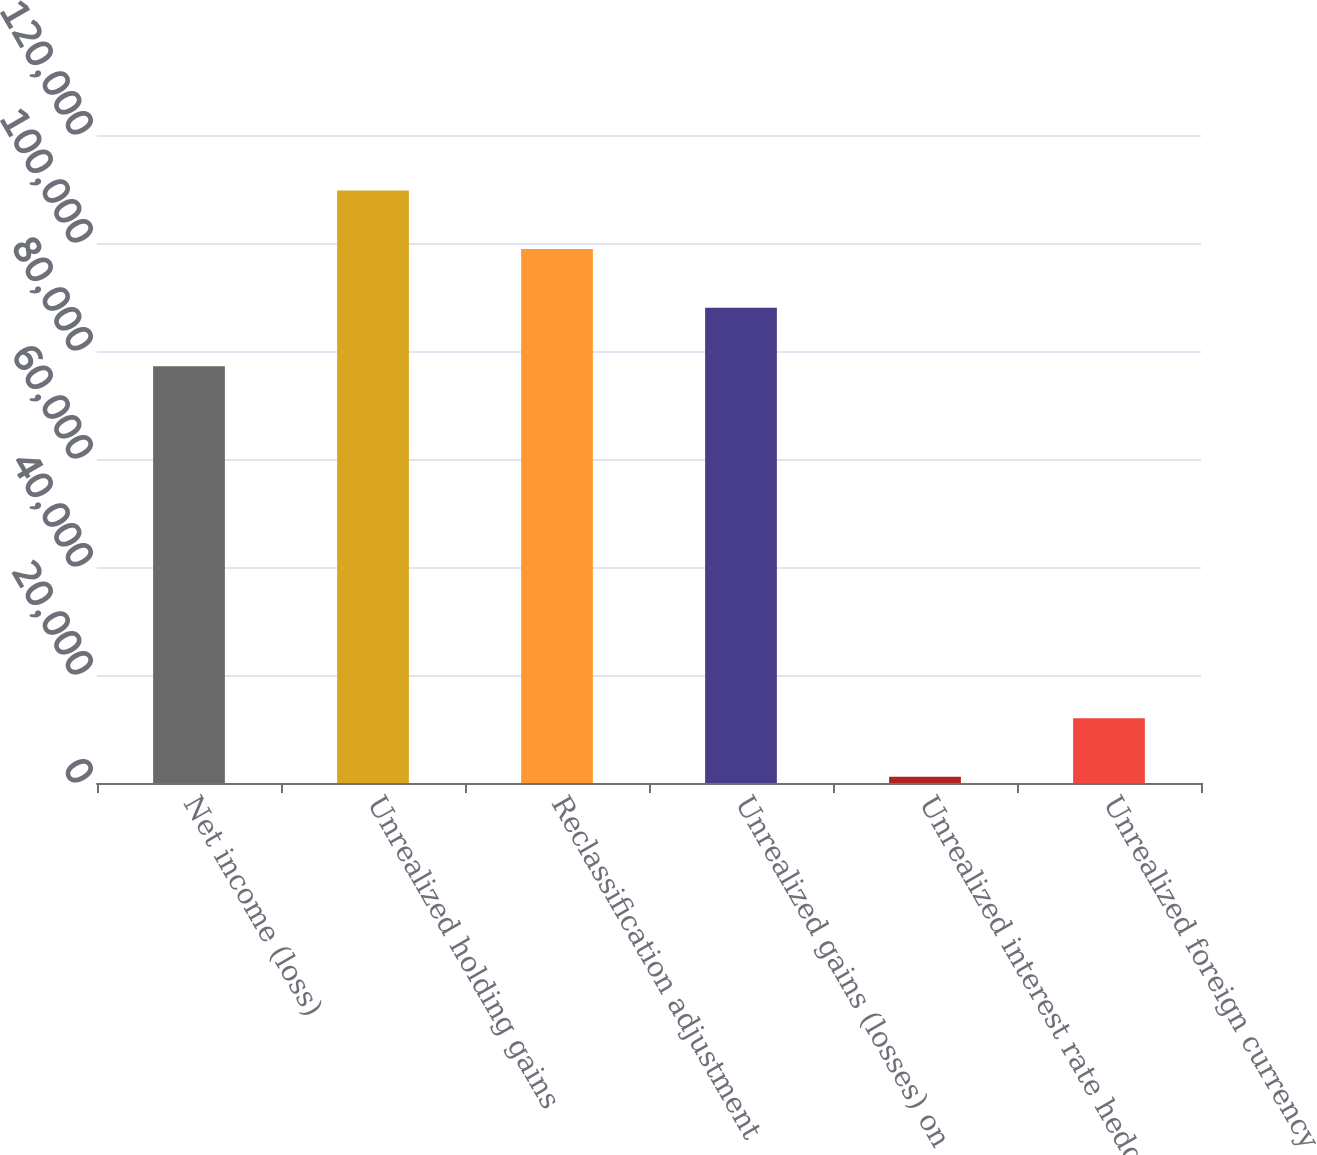<chart> <loc_0><loc_0><loc_500><loc_500><bar_chart><fcel>Net income (loss)<fcel>Unrealized holding gains<fcel>Reclassification adjustment<fcel>Unrealized gains (losses) on<fcel>Unrealized interest rate hedge<fcel>Unrealized foreign currency<nl><fcel>77160.9<fcel>109737<fcel>98878.3<fcel>88019.6<fcel>1150<fcel>12008.7<nl></chart> 